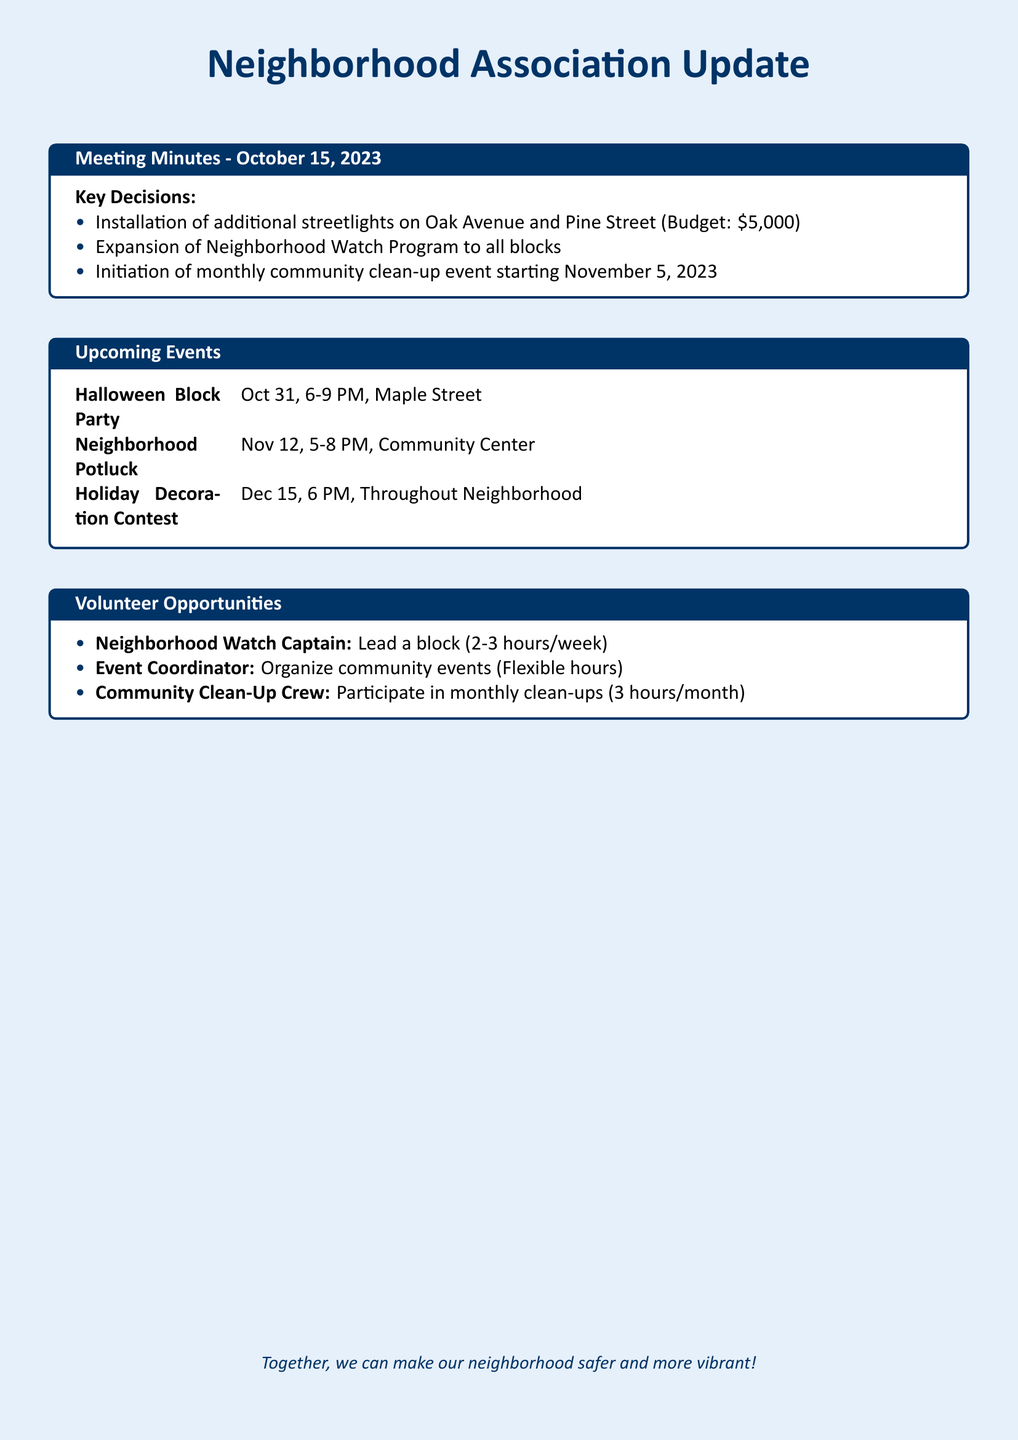What is the date of the Neighborhood Potluck? The document specifies upcoming events, including the Neighborhood Potluck date, which is November 12, 2023.
Answer: November 12, 2023 How much is the budget for streetlight installation? The budget for the installation of additional streetlights is listed in the key decisions section of the document.
Answer: $5,000 What event is scheduled for October 31? The document lists the Halloween Block Party as an upcoming event on October 31, 2023, from 6-9 PM.
Answer: Halloween Block Party How many hours a week is the Neighborhood Watch Captain expected to lead? The document states that the Neighborhood Watch Captain role requires 2-3 hours per week.
Answer: 2-3 hours/week What is the purpose of the monthly community clean-up event? The reasoning behind the initiation of the monthly community clean-up event is to enhance neighborhood cleanliness and involvement, as stated in the key decisions.
Answer: Cleanliness and involvement How many events are mentioned in the Upcoming Events section? By counting the events listed under the Upcoming Events section in the document, we find there are three events mentioned.
Answer: 3 What is the date for the Holiday Decoration Contest? The document provides the date for the Holiday Decoration Contest in the Upcoming Events section, which is December 15.
Answer: December 15 What role is the Event Coordinator responsible for? The document describes the Event Coordinator's responsibility to organize community events, as outlined in the volunteer opportunities section.
Answer: Organize community events When does the community clean-up event start? The document states the initiation date for the community clean-up event is November 5, 2023.
Answer: November 5, 2023 